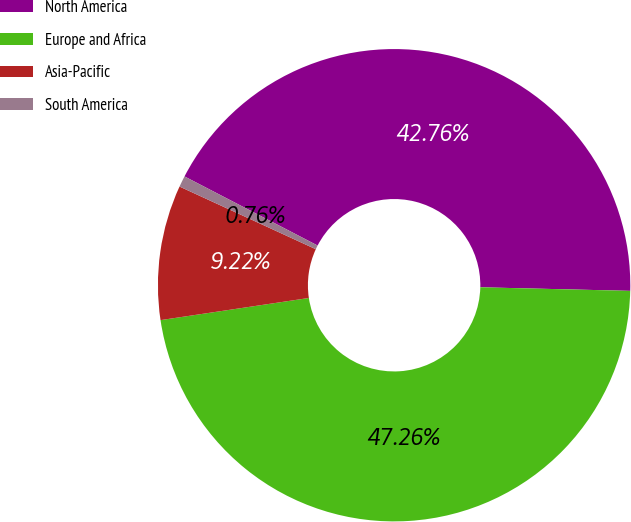<chart> <loc_0><loc_0><loc_500><loc_500><pie_chart><fcel>North America<fcel>Europe and Africa<fcel>Asia-Pacific<fcel>South America<nl><fcel>42.76%<fcel>47.26%<fcel>9.22%<fcel>0.76%<nl></chart> 